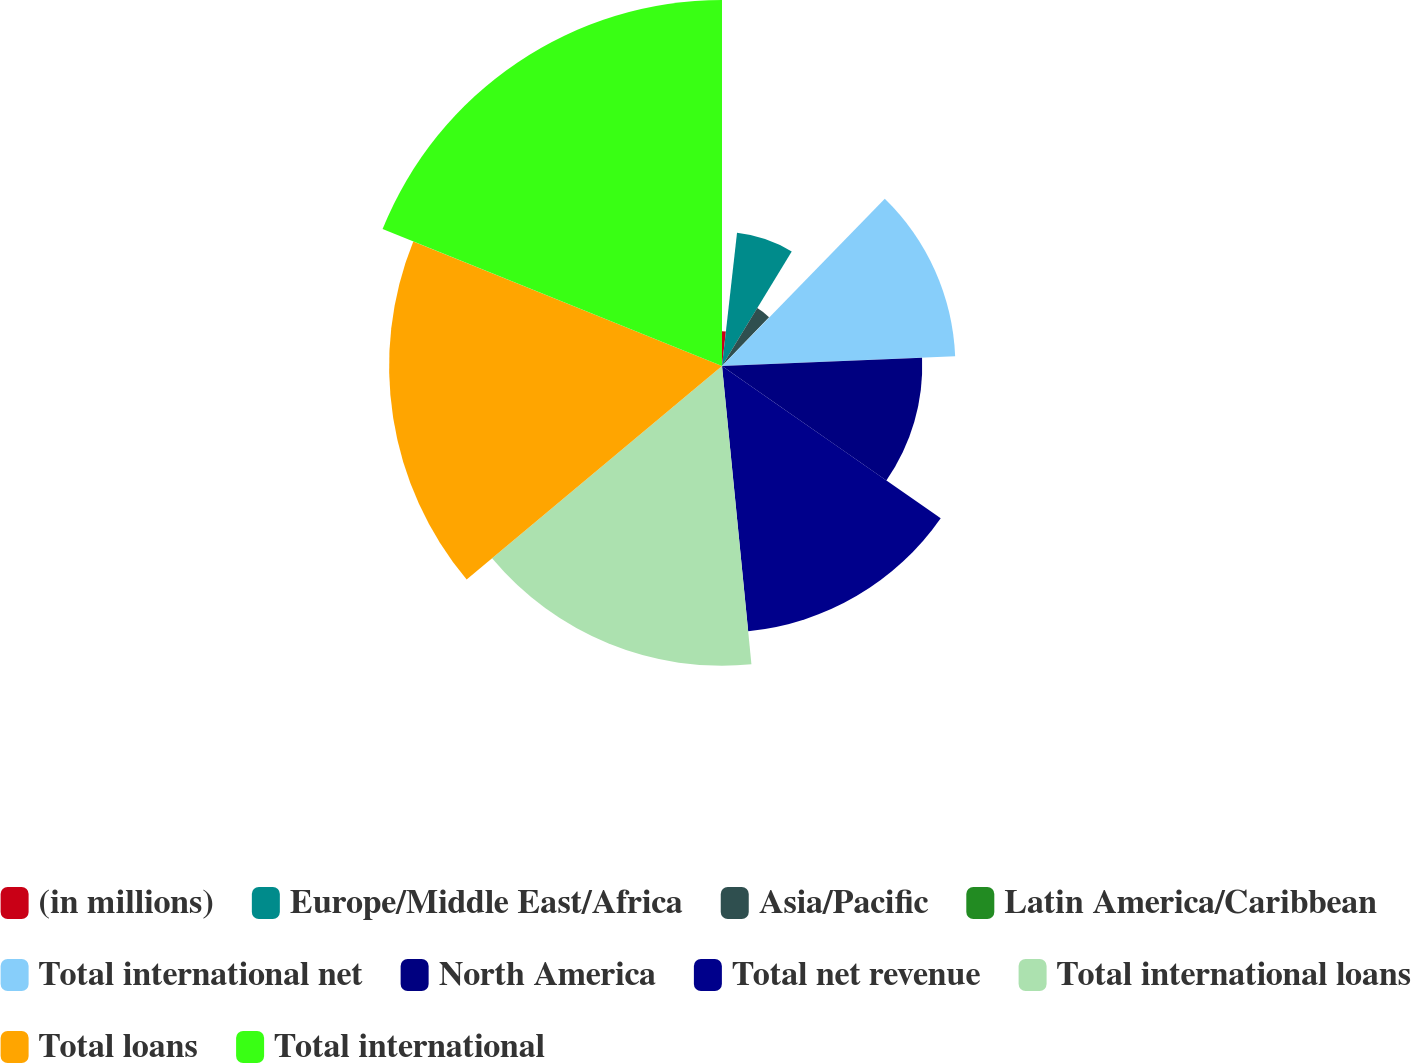Convert chart. <chart><loc_0><loc_0><loc_500><loc_500><pie_chart><fcel>(in millions)<fcel>Europe/Middle East/Africa<fcel>Asia/Pacific<fcel>Latin America/Caribbean<fcel>Total international net<fcel>North America<fcel>Total net revenue<fcel>Total international loans<fcel>Total loans<fcel>Total international<nl><fcel>1.79%<fcel>6.92%<fcel>3.5%<fcel>0.08%<fcel>12.05%<fcel>10.34%<fcel>13.76%<fcel>15.48%<fcel>17.19%<fcel>18.9%<nl></chart> 